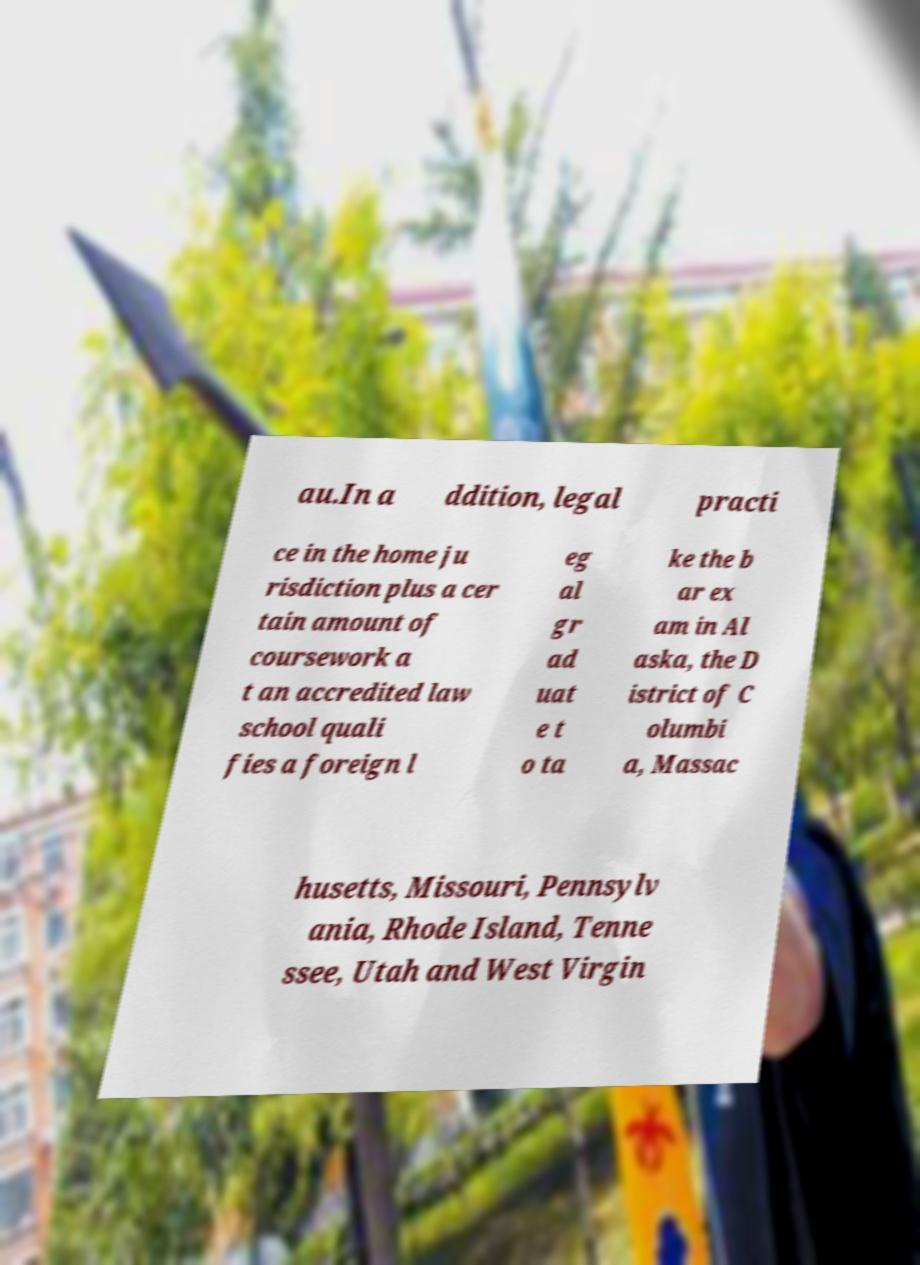Could you extract and type out the text from this image? au.In a ddition, legal practi ce in the home ju risdiction plus a cer tain amount of coursework a t an accredited law school quali fies a foreign l eg al gr ad uat e t o ta ke the b ar ex am in Al aska, the D istrict of C olumbi a, Massac husetts, Missouri, Pennsylv ania, Rhode Island, Tenne ssee, Utah and West Virgin 